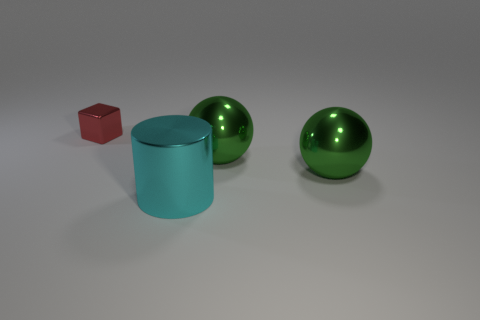Add 1 gray blocks. How many objects exist? 5 Subtract 0 cyan cubes. How many objects are left? 4 Subtract all cylinders. How many objects are left? 3 Subtract all gray blocks. Subtract all gray cylinders. How many blocks are left? 1 Subtract all cyan cylinders. How many cyan cubes are left? 0 Subtract all big matte cylinders. Subtract all cyan cylinders. How many objects are left? 3 Add 2 cyan cylinders. How many cyan cylinders are left? 3 Add 1 small metallic things. How many small metallic things exist? 2 